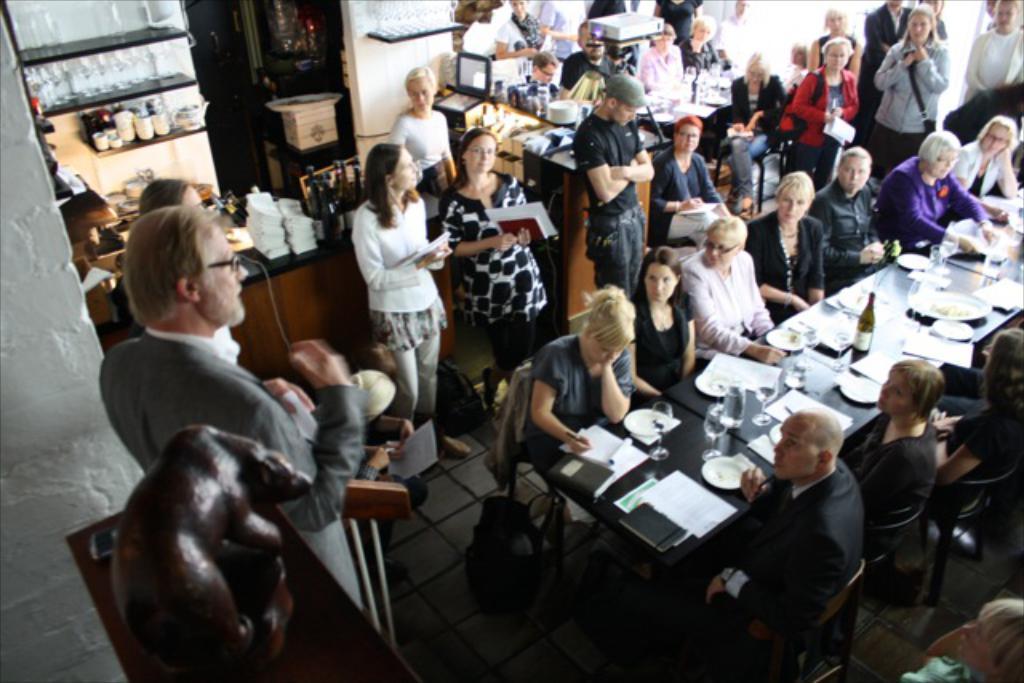In one or two sentences, can you explain what this image depicts? In this image there is a group of persons sitting on the chairs as we can see on the right side of this image. There is a table and there are some paper and some bottles and glasses are kept on it. There are some persons standing in the background. There are some persons standing on the left side of this image as well. there is a wall in the background. There are some bottles kept on a shelf as we can see on the top left corner of this image. There are some bags kept on the floor as we can see in the middle of this image. 